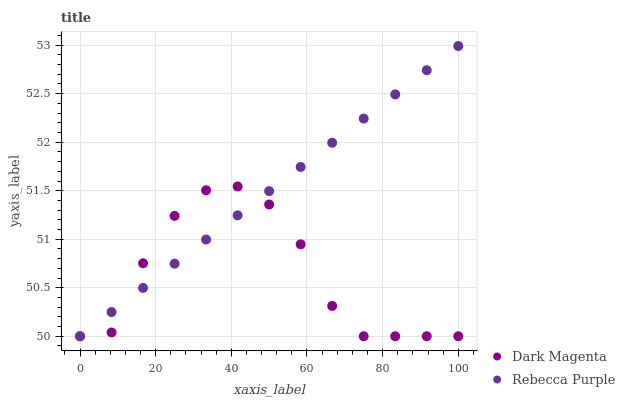Does Dark Magenta have the minimum area under the curve?
Answer yes or no. Yes. Does Rebecca Purple have the maximum area under the curve?
Answer yes or no. Yes. Does Rebecca Purple have the minimum area under the curve?
Answer yes or no. No. Is Rebecca Purple the smoothest?
Answer yes or no. Yes. Is Dark Magenta the roughest?
Answer yes or no. Yes. Is Rebecca Purple the roughest?
Answer yes or no. No. Does Dark Magenta have the lowest value?
Answer yes or no. Yes. Does Rebecca Purple have the highest value?
Answer yes or no. Yes. Does Rebecca Purple intersect Dark Magenta?
Answer yes or no. Yes. Is Rebecca Purple less than Dark Magenta?
Answer yes or no. No. Is Rebecca Purple greater than Dark Magenta?
Answer yes or no. No. 